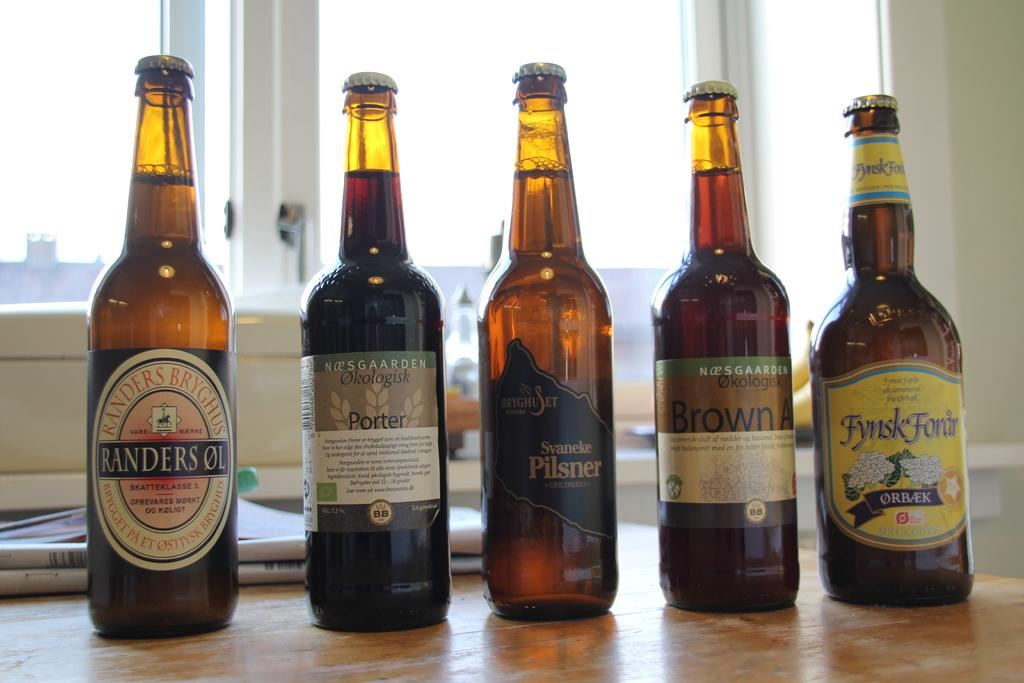<image>
Relay a brief, clear account of the picture shown. Five bottles of beer in front of a window with the first being called Randersol 